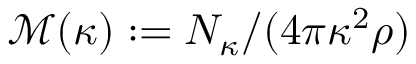Convert formula to latex. <formula><loc_0><loc_0><loc_500><loc_500>\mathcal { M } ( \kappa ) \colon = N _ { \kappa } / ( 4 \pi \kappa ^ { 2 } \rho )</formula> 